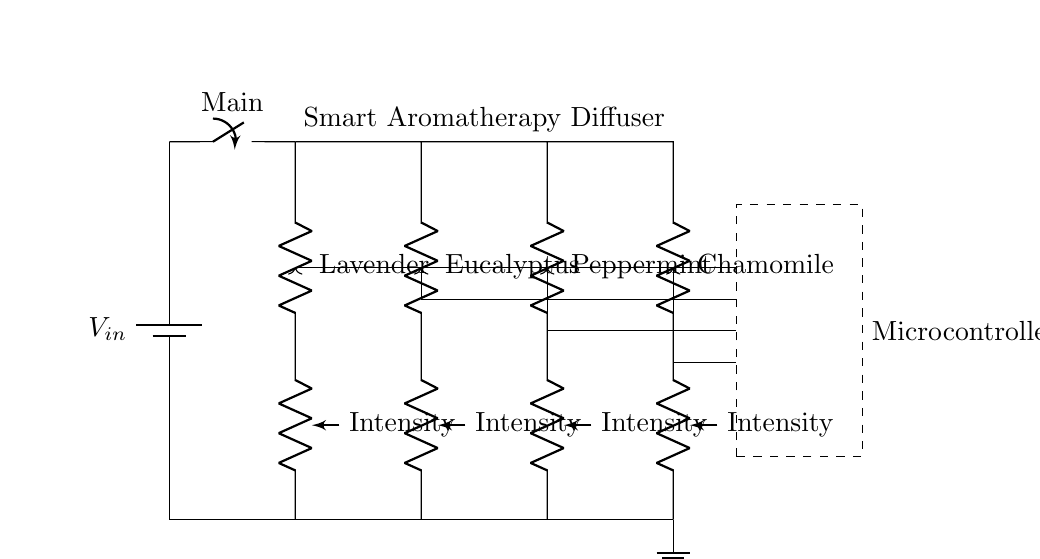What is the power supply used in the circuit? The power supply is represented by the battery symbol at the top left of the circuit diagram, labeled \( V_{in} \).
Answer: Battery What type of circuit configuration is used in this diffuser? The circuit consists of multiple components that are connected across the same two nodes, indicating a parallel circuit configuration.
Answer: Parallel How many scent options are available in this circuit? There are four sets of resistors, each corresponding to a different scent option (Lavender, Eucalyptus, Peppermint, Chamomile), making a total of four scent options.
Answer: Four What component is used to control the intensity of each scent? The component used for controlling the intensity is a potentiometer, as indicated by the symbols next to each resistor for each scent option.
Answer: Potentiometer What is the role of the microcontroller in the circuit? The microcontroller, depicted as a dashed rectangle, likely controls the operation of the aroma diffuser, including scent selection and intensity adjustments, by sending commands to each branch.
Answer: Control Which scent is positioned last in the circuit diagram? Following the order of the resistors, Chamomile is the last scent option displayed on the rightmost side of the diagram.
Answer: Chamomile What does the ground symbol represent in the circuit? The ground symbol at the bottom indicates a common return path for the circuit, providing a reference point for the voltages within the circuit.
Answer: Ground 